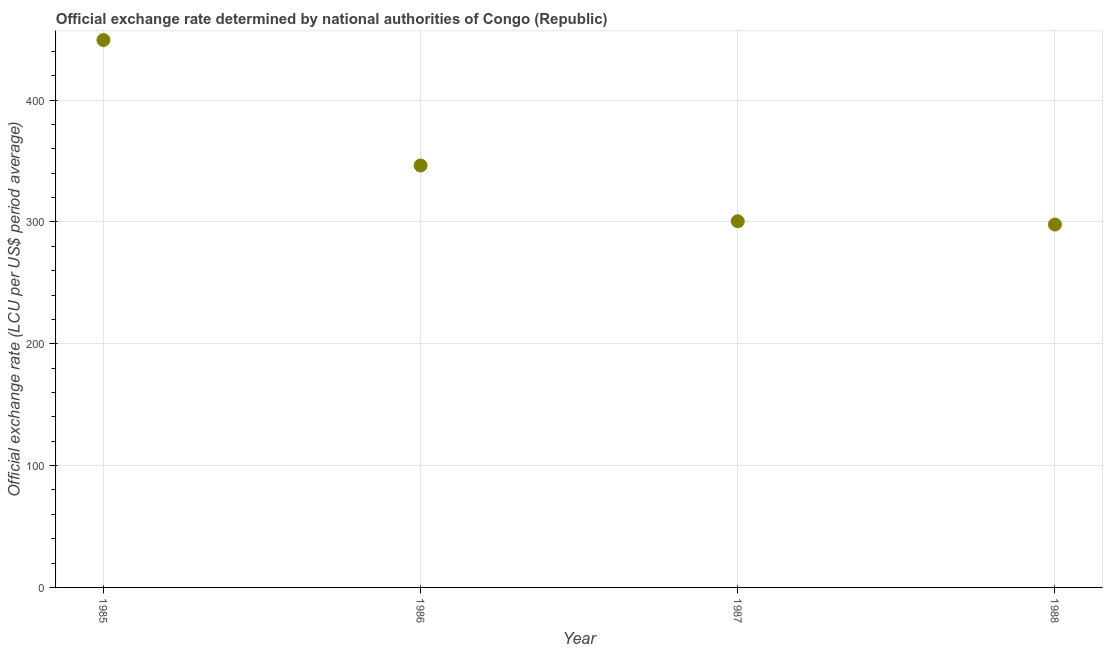What is the official exchange rate in 1986?
Your answer should be very brief. 346.31. Across all years, what is the maximum official exchange rate?
Provide a short and direct response. 449.26. Across all years, what is the minimum official exchange rate?
Offer a very short reply. 297.85. In which year was the official exchange rate maximum?
Keep it short and to the point. 1985. In which year was the official exchange rate minimum?
Give a very brief answer. 1988. What is the sum of the official exchange rate?
Provide a short and direct response. 1393.95. What is the difference between the official exchange rate in 1986 and 1987?
Keep it short and to the point. 45.77. What is the average official exchange rate per year?
Keep it short and to the point. 348.49. What is the median official exchange rate?
Make the answer very short. 323.42. What is the ratio of the official exchange rate in 1986 to that in 1987?
Your response must be concise. 1.15. Is the official exchange rate in 1985 less than that in 1986?
Your response must be concise. No. Is the difference between the official exchange rate in 1986 and 1988 greater than the difference between any two years?
Keep it short and to the point. No. What is the difference between the highest and the second highest official exchange rate?
Your answer should be very brief. 102.96. What is the difference between the highest and the lowest official exchange rate?
Your answer should be very brief. 151.41. How many years are there in the graph?
Offer a terse response. 4. What is the difference between two consecutive major ticks on the Y-axis?
Make the answer very short. 100. Are the values on the major ticks of Y-axis written in scientific E-notation?
Provide a short and direct response. No. Does the graph contain any zero values?
Keep it short and to the point. No. Does the graph contain grids?
Provide a short and direct response. Yes. What is the title of the graph?
Ensure brevity in your answer.  Official exchange rate determined by national authorities of Congo (Republic). What is the label or title of the X-axis?
Provide a short and direct response. Year. What is the label or title of the Y-axis?
Make the answer very short. Official exchange rate (LCU per US$ period average). What is the Official exchange rate (LCU per US$ period average) in 1985?
Make the answer very short. 449.26. What is the Official exchange rate (LCU per US$ period average) in 1986?
Your answer should be very brief. 346.31. What is the Official exchange rate (LCU per US$ period average) in 1987?
Your response must be concise. 300.54. What is the Official exchange rate (LCU per US$ period average) in 1988?
Provide a succinct answer. 297.85. What is the difference between the Official exchange rate (LCU per US$ period average) in 1985 and 1986?
Keep it short and to the point. 102.96. What is the difference between the Official exchange rate (LCU per US$ period average) in 1985 and 1987?
Provide a succinct answer. 148.73. What is the difference between the Official exchange rate (LCU per US$ period average) in 1985 and 1988?
Your response must be concise. 151.41. What is the difference between the Official exchange rate (LCU per US$ period average) in 1986 and 1987?
Provide a succinct answer. 45.77. What is the difference between the Official exchange rate (LCU per US$ period average) in 1986 and 1988?
Offer a terse response. 48.46. What is the difference between the Official exchange rate (LCU per US$ period average) in 1987 and 1988?
Your answer should be very brief. 2.69. What is the ratio of the Official exchange rate (LCU per US$ period average) in 1985 to that in 1986?
Your answer should be compact. 1.3. What is the ratio of the Official exchange rate (LCU per US$ period average) in 1985 to that in 1987?
Offer a very short reply. 1.5. What is the ratio of the Official exchange rate (LCU per US$ period average) in 1985 to that in 1988?
Give a very brief answer. 1.51. What is the ratio of the Official exchange rate (LCU per US$ period average) in 1986 to that in 1987?
Provide a short and direct response. 1.15. What is the ratio of the Official exchange rate (LCU per US$ period average) in 1986 to that in 1988?
Offer a very short reply. 1.16. 